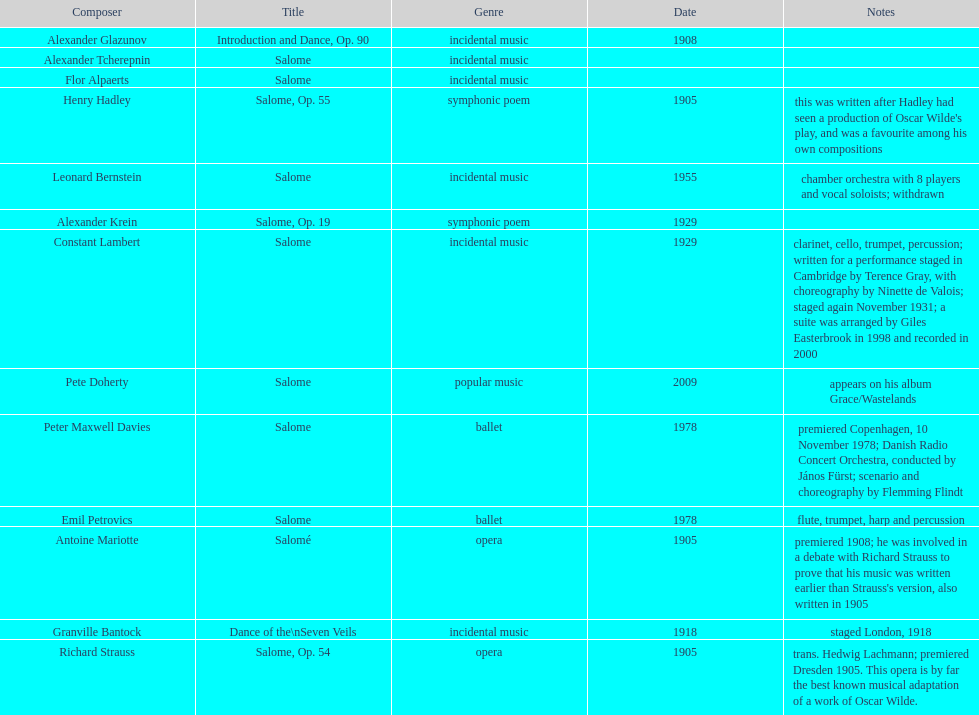What work was written after henry hadley had seen an oscar wilde play? Salome, Op. 55. 